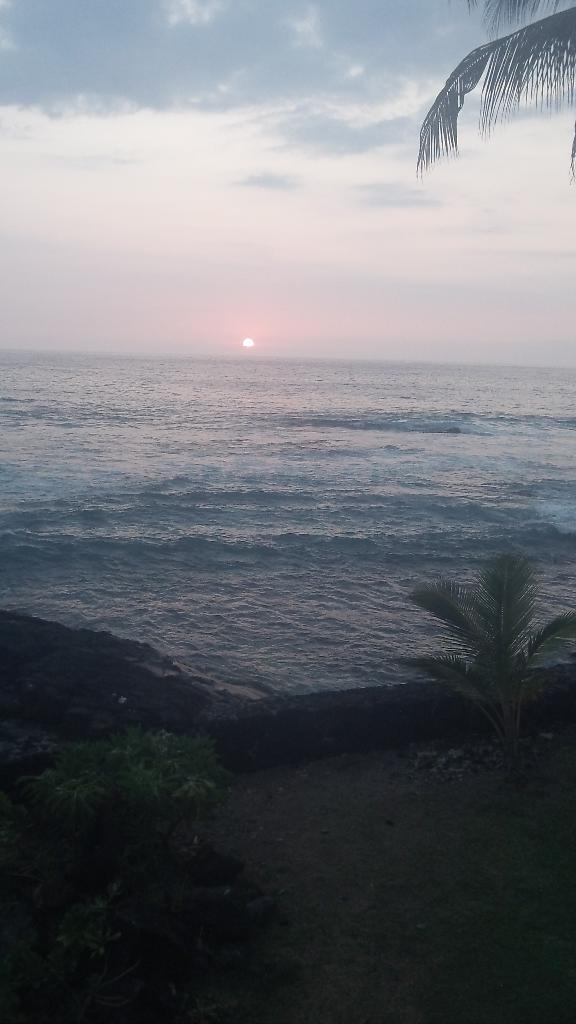What natural feature is present in the image? The image contains the sea. What type of vegetation can be seen in the image? There are plants visible in the image. How would you describe the weather in the image? The sky is cloudy in the image, which suggests a partly cloudy or overcast day. Can the sun be seen in the image? Yes, the sun is observable in the image. What type of scent can be detected in the image? There is no information about scents in the image, as it only provides visual information. 